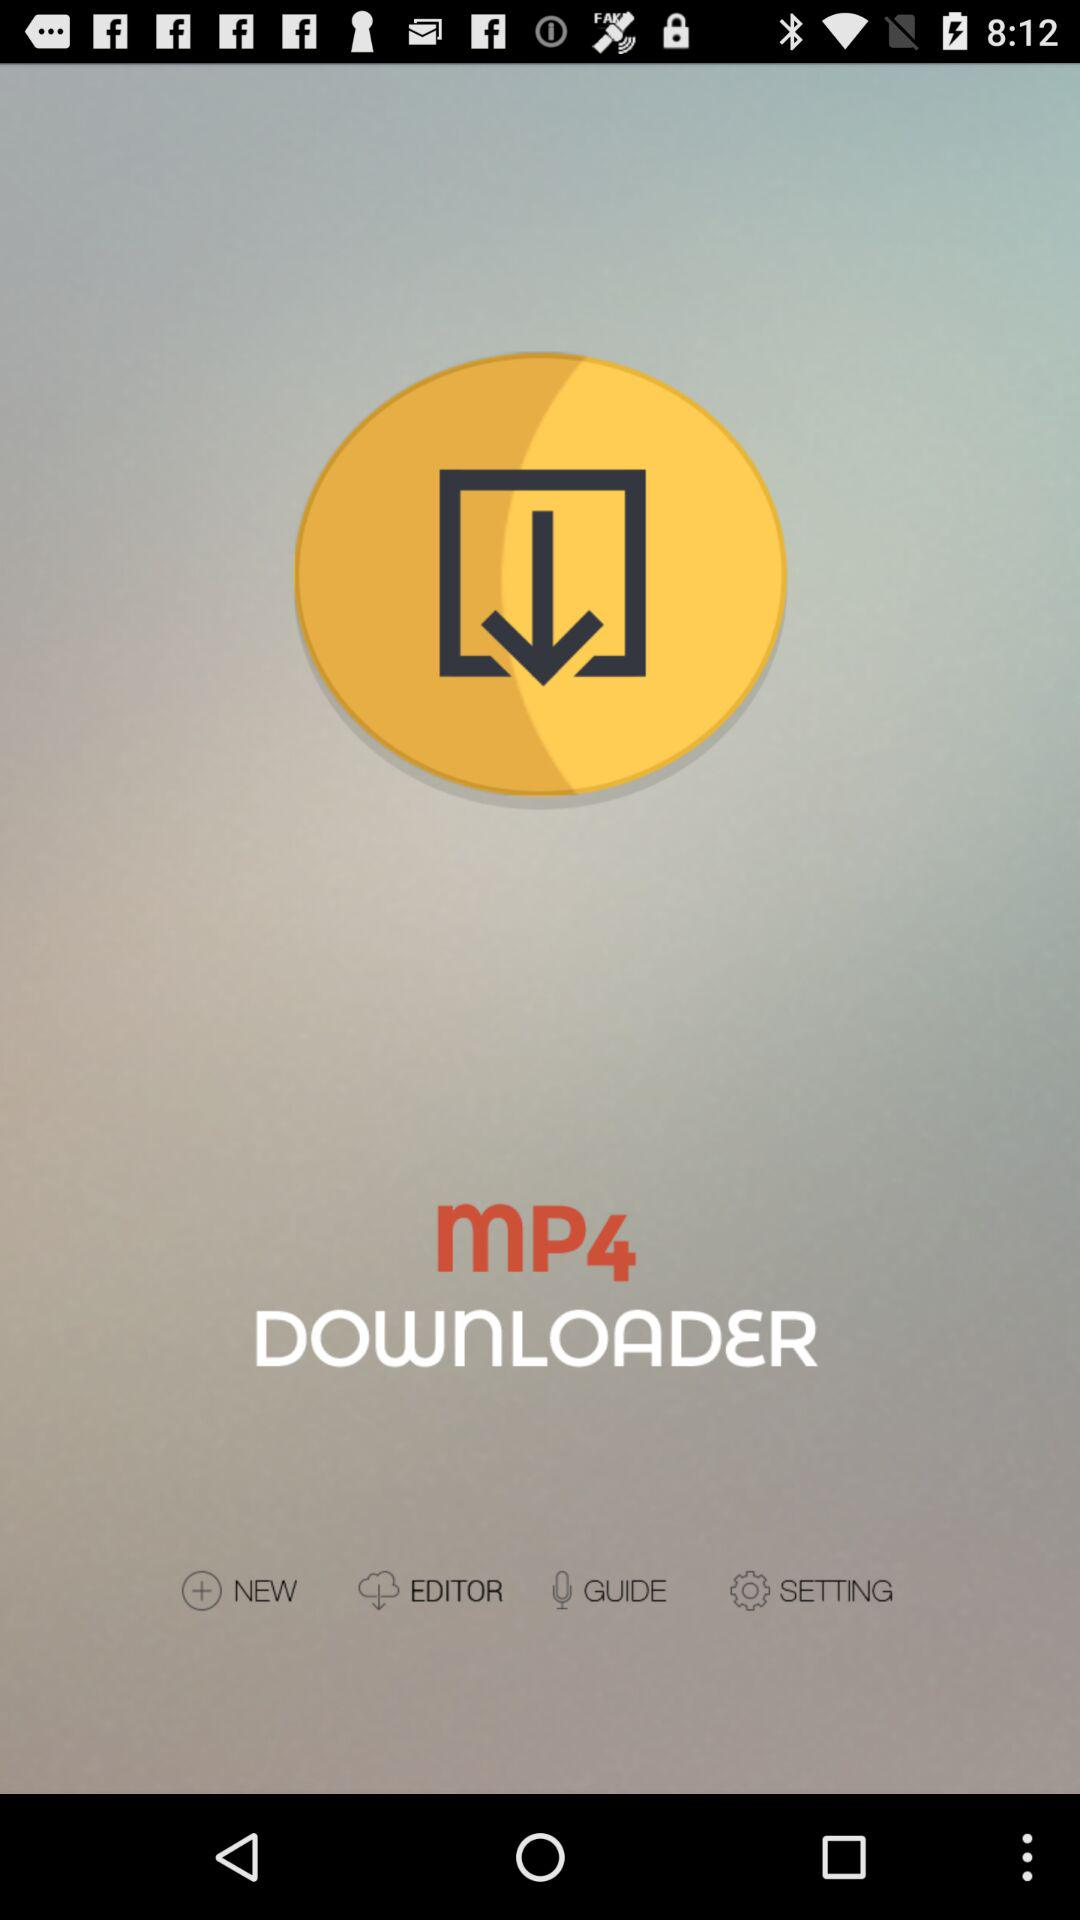Are there any MP4s downloaded?
When the provided information is insufficient, respond with <no answer>. <no answer> 